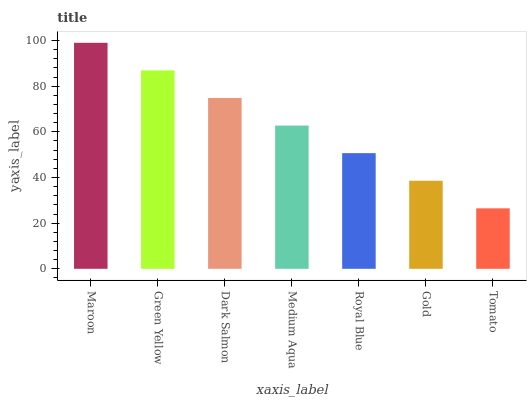Is Tomato the minimum?
Answer yes or no. Yes. Is Maroon the maximum?
Answer yes or no. Yes. Is Green Yellow the minimum?
Answer yes or no. No. Is Green Yellow the maximum?
Answer yes or no. No. Is Maroon greater than Green Yellow?
Answer yes or no. Yes. Is Green Yellow less than Maroon?
Answer yes or no. Yes. Is Green Yellow greater than Maroon?
Answer yes or no. No. Is Maroon less than Green Yellow?
Answer yes or no. No. Is Medium Aqua the high median?
Answer yes or no. Yes. Is Medium Aqua the low median?
Answer yes or no. Yes. Is Royal Blue the high median?
Answer yes or no. No. Is Green Yellow the low median?
Answer yes or no. No. 